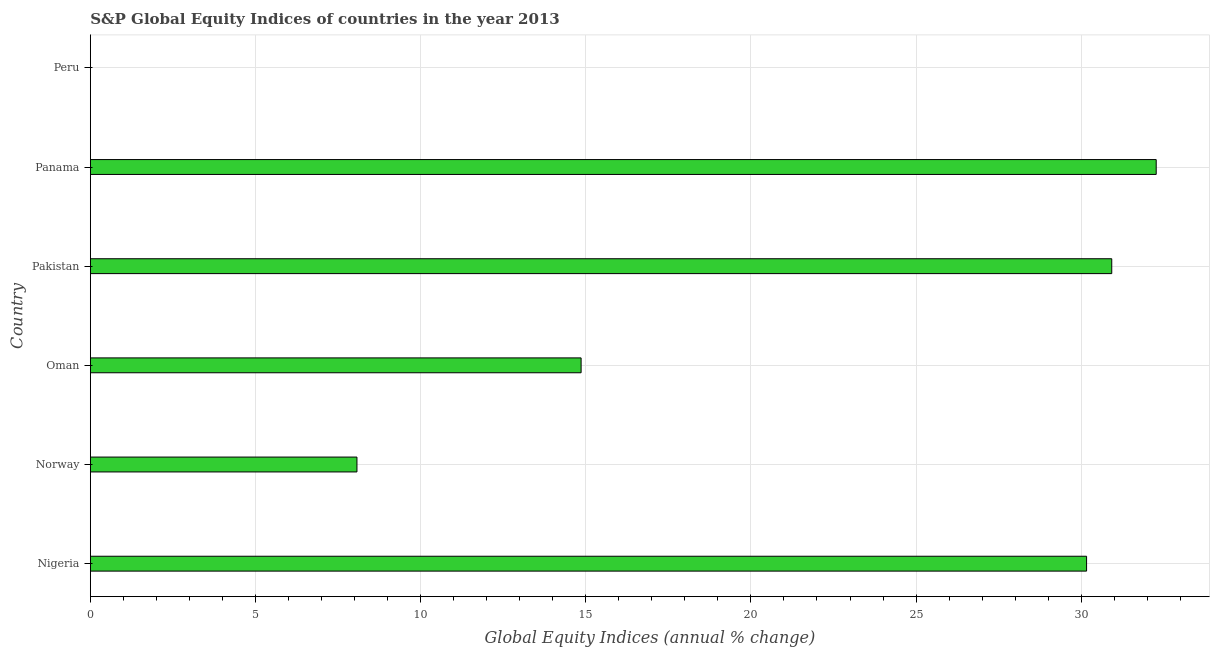Does the graph contain grids?
Your answer should be compact. Yes. What is the title of the graph?
Provide a short and direct response. S&P Global Equity Indices of countries in the year 2013. What is the label or title of the X-axis?
Provide a short and direct response. Global Equity Indices (annual % change). What is the s&p global equity indices in Pakistan?
Offer a terse response. 30.92. Across all countries, what is the maximum s&p global equity indices?
Ensure brevity in your answer.  32.27. In which country was the s&p global equity indices maximum?
Provide a short and direct response. Panama. What is the sum of the s&p global equity indices?
Offer a very short reply. 116.29. What is the difference between the s&p global equity indices in Nigeria and Pakistan?
Make the answer very short. -0.76. What is the average s&p global equity indices per country?
Provide a succinct answer. 19.38. What is the median s&p global equity indices?
Provide a short and direct response. 22.51. In how many countries, is the s&p global equity indices greater than 28 %?
Your answer should be compact. 3. What is the ratio of the s&p global equity indices in Nigeria to that in Oman?
Your response must be concise. 2.03. Is the difference between the s&p global equity indices in Norway and Oman greater than the difference between any two countries?
Make the answer very short. No. What is the difference between the highest and the second highest s&p global equity indices?
Keep it short and to the point. 1.35. What is the difference between the highest and the lowest s&p global equity indices?
Make the answer very short. 32.27. How many bars are there?
Provide a short and direct response. 5. What is the difference between two consecutive major ticks on the X-axis?
Keep it short and to the point. 5. What is the Global Equity Indices (annual % change) in Nigeria?
Your answer should be compact. 30.16. What is the Global Equity Indices (annual % change) of Norway?
Give a very brief answer. 8.07. What is the Global Equity Indices (annual % change) of Oman?
Provide a succinct answer. 14.86. What is the Global Equity Indices (annual % change) in Pakistan?
Provide a succinct answer. 30.92. What is the Global Equity Indices (annual % change) in Panama?
Ensure brevity in your answer.  32.27. What is the Global Equity Indices (annual % change) of Peru?
Provide a short and direct response. 0. What is the difference between the Global Equity Indices (annual % change) in Nigeria and Norway?
Your answer should be very brief. 22.09. What is the difference between the Global Equity Indices (annual % change) in Nigeria and Oman?
Ensure brevity in your answer.  15.3. What is the difference between the Global Equity Indices (annual % change) in Nigeria and Pakistan?
Provide a succinct answer. -0.76. What is the difference between the Global Equity Indices (annual % change) in Nigeria and Panama?
Give a very brief answer. -2.11. What is the difference between the Global Equity Indices (annual % change) in Norway and Oman?
Provide a succinct answer. -6.79. What is the difference between the Global Equity Indices (annual % change) in Norway and Pakistan?
Give a very brief answer. -22.85. What is the difference between the Global Equity Indices (annual % change) in Norway and Panama?
Ensure brevity in your answer.  -24.2. What is the difference between the Global Equity Indices (annual % change) in Oman and Pakistan?
Make the answer very short. -16.07. What is the difference between the Global Equity Indices (annual % change) in Oman and Panama?
Offer a terse response. -17.41. What is the difference between the Global Equity Indices (annual % change) in Pakistan and Panama?
Provide a short and direct response. -1.35. What is the ratio of the Global Equity Indices (annual % change) in Nigeria to that in Norway?
Your response must be concise. 3.74. What is the ratio of the Global Equity Indices (annual % change) in Nigeria to that in Oman?
Provide a short and direct response. 2.03. What is the ratio of the Global Equity Indices (annual % change) in Nigeria to that in Pakistan?
Ensure brevity in your answer.  0.97. What is the ratio of the Global Equity Indices (annual % change) in Nigeria to that in Panama?
Make the answer very short. 0.94. What is the ratio of the Global Equity Indices (annual % change) in Norway to that in Oman?
Your answer should be compact. 0.54. What is the ratio of the Global Equity Indices (annual % change) in Norway to that in Pakistan?
Provide a short and direct response. 0.26. What is the ratio of the Global Equity Indices (annual % change) in Oman to that in Pakistan?
Your answer should be compact. 0.48. What is the ratio of the Global Equity Indices (annual % change) in Oman to that in Panama?
Provide a succinct answer. 0.46. What is the ratio of the Global Equity Indices (annual % change) in Pakistan to that in Panama?
Give a very brief answer. 0.96. 